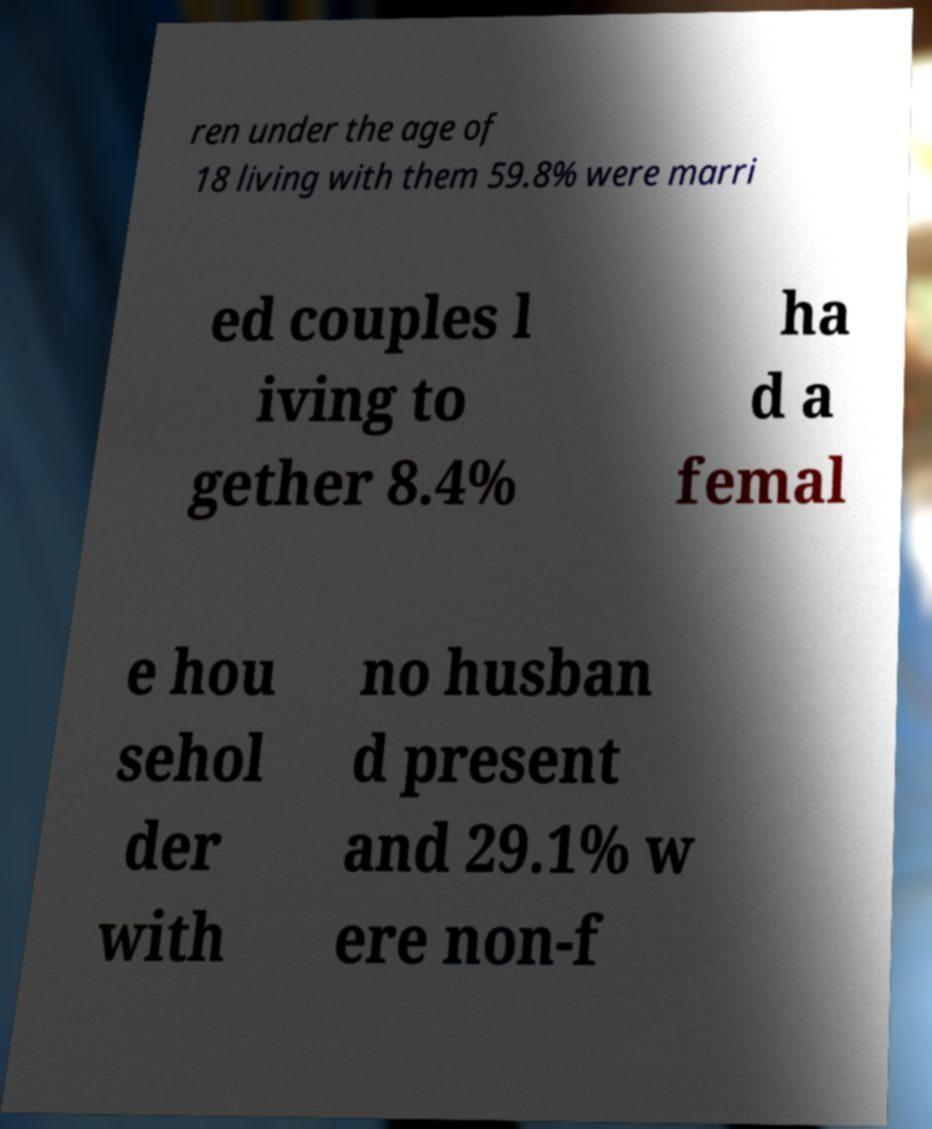There's text embedded in this image that I need extracted. Can you transcribe it verbatim? ren under the age of 18 living with them 59.8% were marri ed couples l iving to gether 8.4% ha d a femal e hou sehol der with no husban d present and 29.1% w ere non-f 